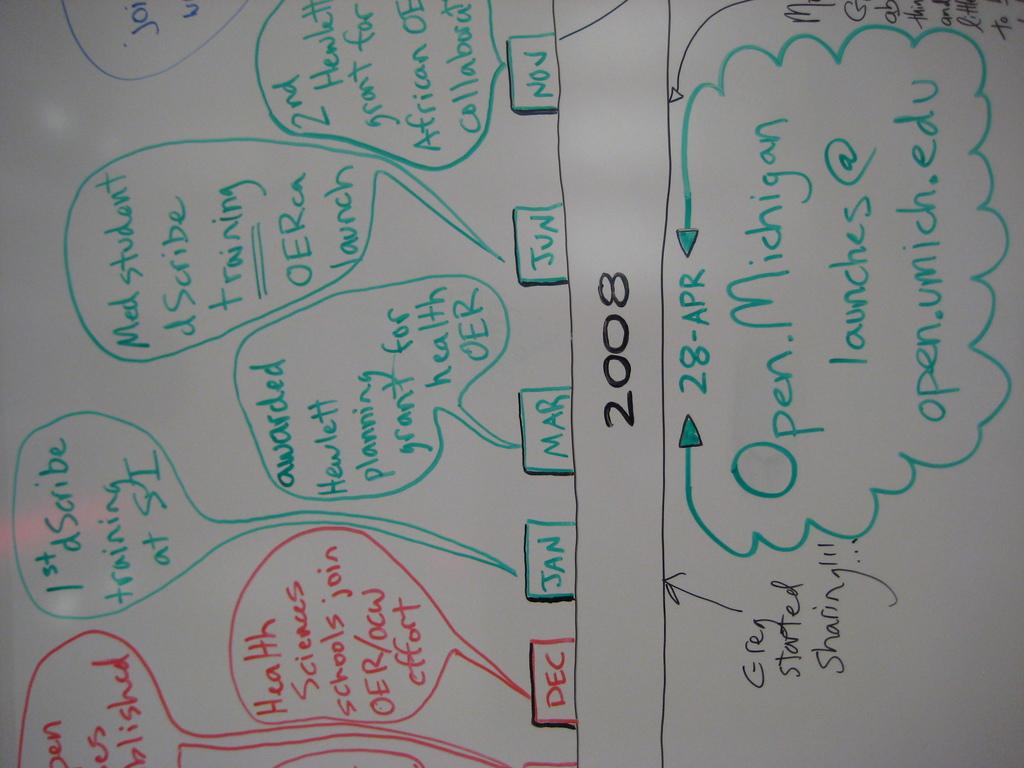What email is written at the bottom?
Make the answer very short. Open.umich.edu. What year is on the whiteboard?
Keep it short and to the point. 2008. 